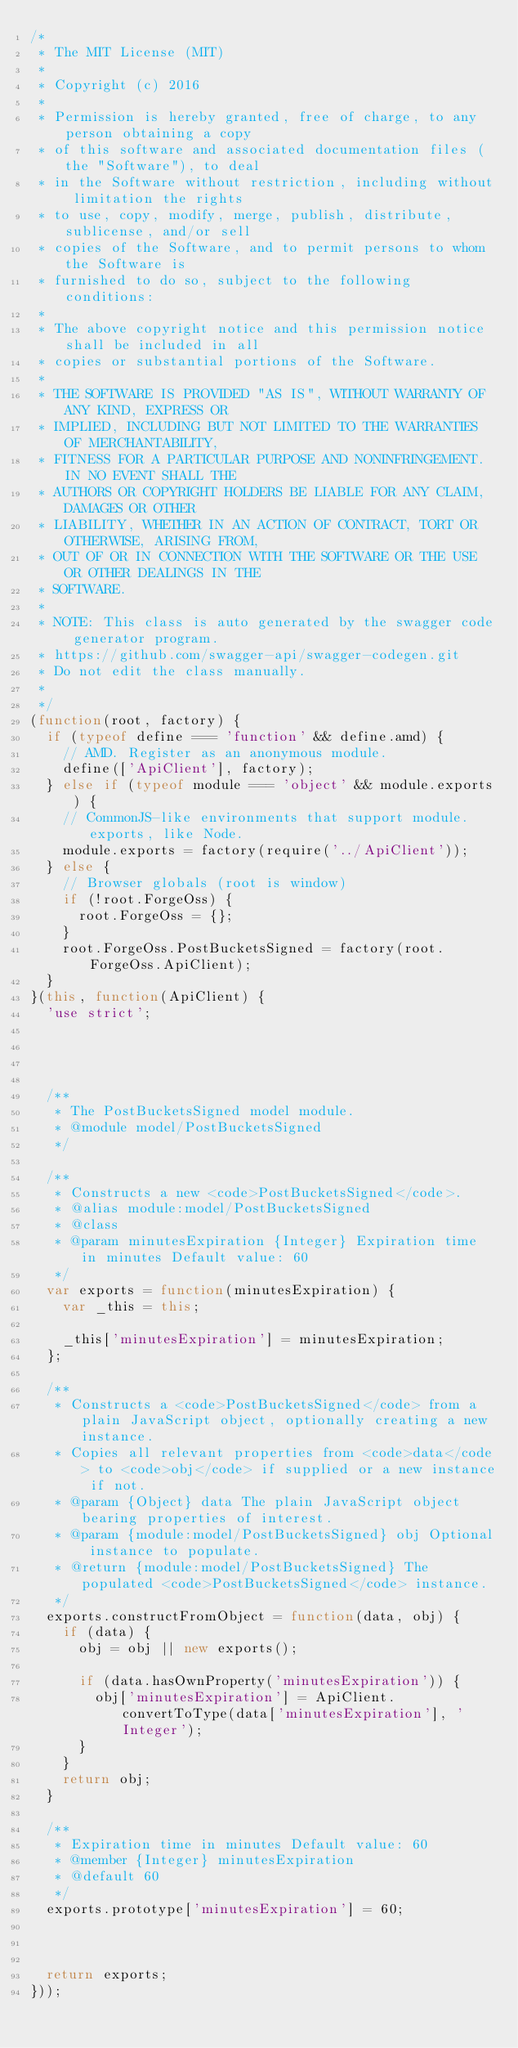Convert code to text. <code><loc_0><loc_0><loc_500><loc_500><_JavaScript_>/*
 * The MIT License (MIT)
 *
 * Copyright (c) 2016 
 *
 * Permission is hereby granted, free of charge, to any person obtaining a copy
 * of this software and associated documentation files (the "Software"), to deal
 * in the Software without restriction, including without limitation the rights
 * to use, copy, modify, merge, publish, distribute, sublicense, and/or sell
 * copies of the Software, and to permit persons to whom the Software is
 * furnished to do so, subject to the following conditions:
 *
 * The above copyright notice and this permission notice shall be included in all
 * copies or substantial portions of the Software.
 *
 * THE SOFTWARE IS PROVIDED "AS IS", WITHOUT WARRANTY OF ANY KIND, EXPRESS OR
 * IMPLIED, INCLUDING BUT NOT LIMITED TO THE WARRANTIES OF MERCHANTABILITY,
 * FITNESS FOR A PARTICULAR PURPOSE AND NONINFRINGEMENT. IN NO EVENT SHALL THE
 * AUTHORS OR COPYRIGHT HOLDERS BE LIABLE FOR ANY CLAIM, DAMAGES OR OTHER
 * LIABILITY, WHETHER IN AN ACTION OF CONTRACT, TORT OR OTHERWISE, ARISING FROM,
 * OUT OF OR IN CONNECTION WITH THE SOFTWARE OR THE USE OR OTHER DEALINGS IN THE
 * SOFTWARE.
 *
 * NOTE: This class is auto generated by the swagger code generator program.
 * https://github.com/swagger-api/swagger-codegen.git
 * Do not edit the class manually.
 *
 */
(function(root, factory) {
  if (typeof define === 'function' && define.amd) {
    // AMD. Register as an anonymous module.
    define(['ApiClient'], factory);
  } else if (typeof module === 'object' && module.exports) {
    // CommonJS-like environments that support module.exports, like Node.
    module.exports = factory(require('../ApiClient'));
  } else {
    // Browser globals (root is window)
    if (!root.ForgeOss) {
      root.ForgeOss = {};
    }
    root.ForgeOss.PostBucketsSigned = factory(root.ForgeOss.ApiClient);
  }
}(this, function(ApiClient) {
  'use strict';




  /**
   * The PostBucketsSigned model module.
   * @module model/PostBucketsSigned
   */

  /**
   * Constructs a new <code>PostBucketsSigned</code>.
   * @alias module:model/PostBucketsSigned
   * @class
   * @param minutesExpiration {Integer} Expiration time in minutes Default value: 60 
   */
  var exports = function(minutesExpiration) {
    var _this = this;

    _this['minutesExpiration'] = minutesExpiration;
  };

  /**
   * Constructs a <code>PostBucketsSigned</code> from a plain JavaScript object, optionally creating a new instance.
   * Copies all relevant properties from <code>data</code> to <code>obj</code> if supplied or a new instance if not.
   * @param {Object} data The plain JavaScript object bearing properties of interest.
   * @param {module:model/PostBucketsSigned} obj Optional instance to populate.
   * @return {module:model/PostBucketsSigned} The populated <code>PostBucketsSigned</code> instance.
   */
  exports.constructFromObject = function(data, obj) {
    if (data) {
      obj = obj || new exports();

      if (data.hasOwnProperty('minutesExpiration')) {
        obj['minutesExpiration'] = ApiClient.convertToType(data['minutesExpiration'], 'Integer');
      }
    }
    return obj;
  }

  /**
   * Expiration time in minutes Default value: 60 
   * @member {Integer} minutesExpiration
   * @default 60
   */
  exports.prototype['minutesExpiration'] = 60;



  return exports;
}));


</code> 